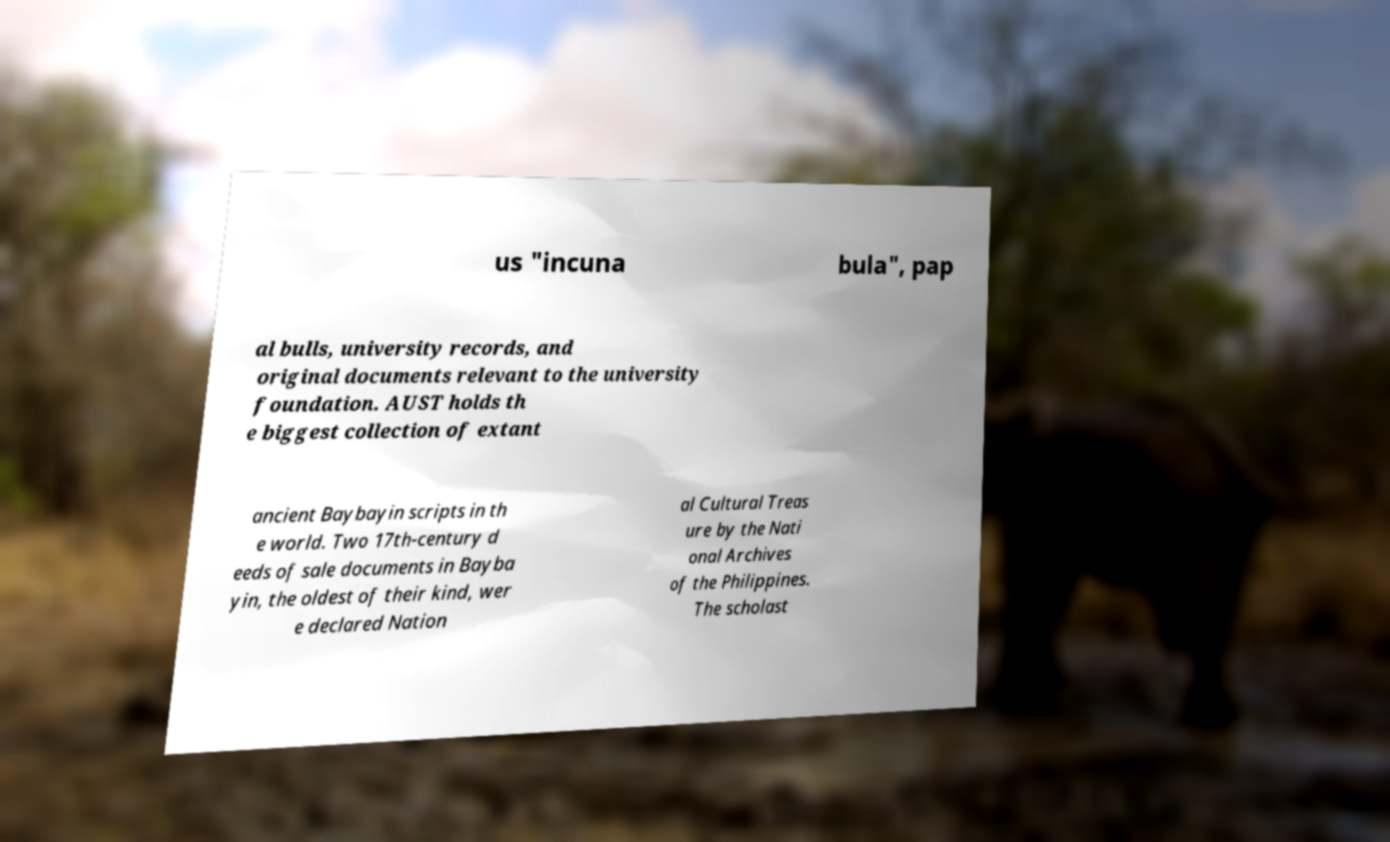For documentation purposes, I need the text within this image transcribed. Could you provide that? us "incuna bula", pap al bulls, university records, and original documents relevant to the university foundation. AUST holds th e biggest collection of extant ancient Baybayin scripts in th e world. Two 17th-century d eeds of sale documents in Bayba yin, the oldest of their kind, wer e declared Nation al Cultural Treas ure by the Nati onal Archives of the Philippines. The scholast 